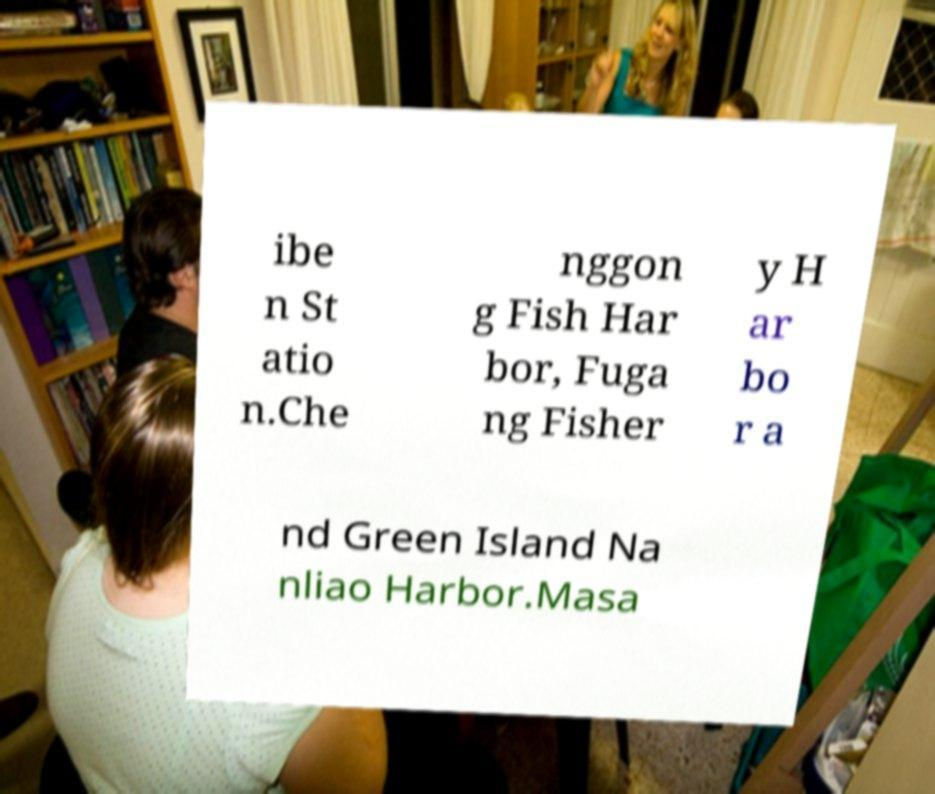Could you extract and type out the text from this image? ibe n St atio n.Che nggon g Fish Har bor, Fuga ng Fisher y H ar bo r a nd Green Island Na nliao Harbor.Masa 